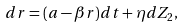<formula> <loc_0><loc_0><loc_500><loc_500>d r = ( a - \beta r ) d t + \eta d Z _ { 2 } ,</formula> 